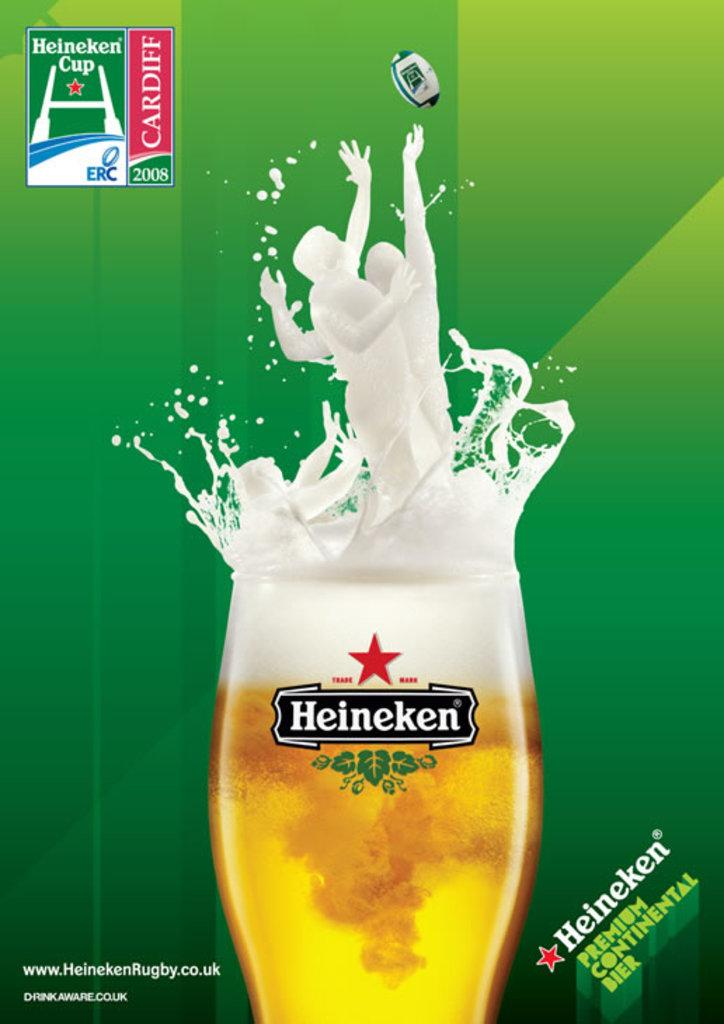<image>
Relay a brief, clear account of the picture shown. A glass Heineken beer ad with a beer glass overfilling with beer. 